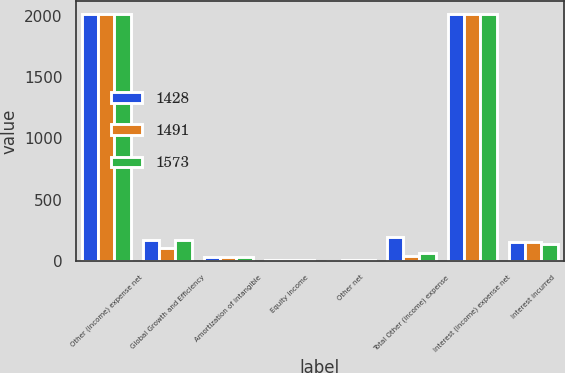<chart> <loc_0><loc_0><loc_500><loc_500><stacked_bar_chart><ecel><fcel>Other (income) expense net<fcel>Global Growth and Efficiency<fcel>Amortization of intangible<fcel>Equity income<fcel>Other net<fcel>Total Other (income) expense<fcel>Interest (income) expense net<fcel>Interest incurred<nl><fcel>1428<fcel>2017<fcel>169<fcel>35<fcel>11<fcel>1<fcel>194<fcel>2017<fcel>156<nl><fcel>1491<fcel>2016<fcel>105<fcel>33<fcel>10<fcel>11<fcel>37<fcel>2016<fcel>155<nl><fcel>1573<fcel>2015<fcel>170<fcel>33<fcel>8<fcel>6<fcel>62<fcel>2015<fcel>139<nl></chart> 